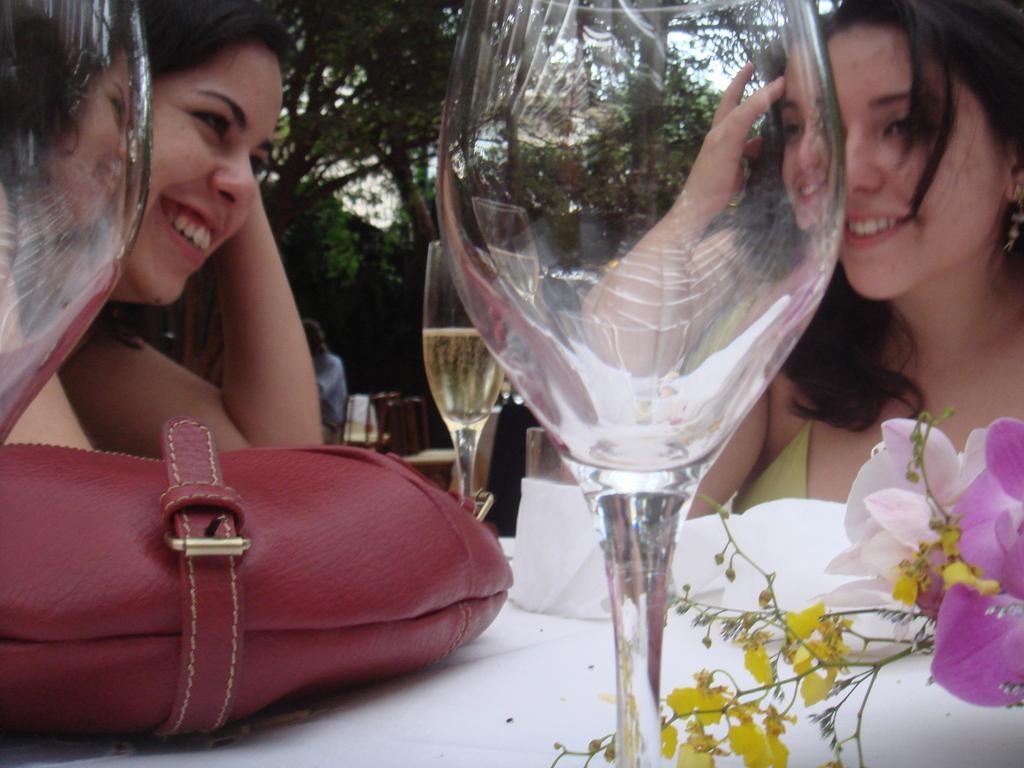Describe this image in one or two sentences. In this picture that two women sitting on a table, a red bag placed on the table and both of them are smiling 